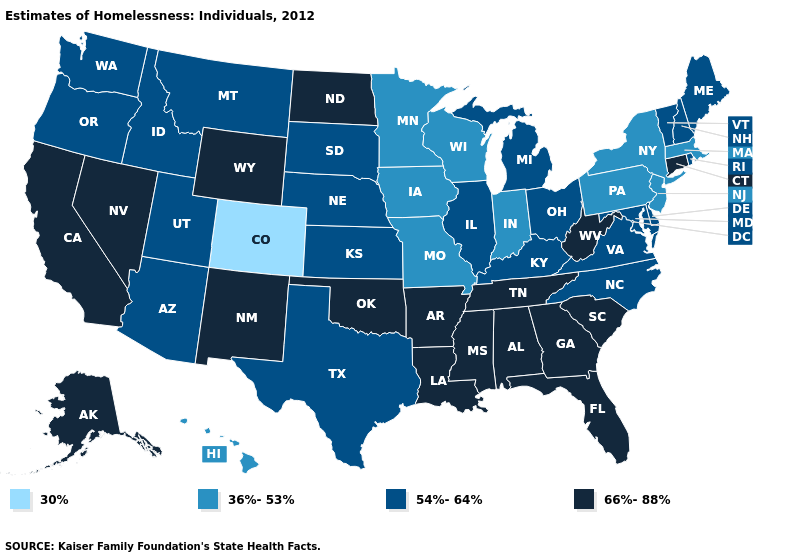Name the states that have a value in the range 54%-64%?
Short answer required. Arizona, Delaware, Idaho, Illinois, Kansas, Kentucky, Maine, Maryland, Michigan, Montana, Nebraska, New Hampshire, North Carolina, Ohio, Oregon, Rhode Island, South Dakota, Texas, Utah, Vermont, Virginia, Washington. Name the states that have a value in the range 66%-88%?
Write a very short answer. Alabama, Alaska, Arkansas, California, Connecticut, Florida, Georgia, Louisiana, Mississippi, Nevada, New Mexico, North Dakota, Oklahoma, South Carolina, Tennessee, West Virginia, Wyoming. Does Kansas have the same value as Idaho?
Concise answer only. Yes. Does Louisiana have a lower value than New Jersey?
Quick response, please. No. What is the value of Nevada?
Keep it brief. 66%-88%. Which states hav the highest value in the MidWest?
Quick response, please. North Dakota. Name the states that have a value in the range 30%?
Give a very brief answer. Colorado. Does the first symbol in the legend represent the smallest category?
Concise answer only. Yes. What is the value of Maryland?
Quick response, please. 54%-64%. What is the value of South Dakota?
Be succinct. 54%-64%. Name the states that have a value in the range 30%?
Answer briefly. Colorado. Name the states that have a value in the range 36%-53%?
Be succinct. Hawaii, Indiana, Iowa, Massachusetts, Minnesota, Missouri, New Jersey, New York, Pennsylvania, Wisconsin. Which states have the highest value in the USA?
Keep it brief. Alabama, Alaska, Arkansas, California, Connecticut, Florida, Georgia, Louisiana, Mississippi, Nevada, New Mexico, North Dakota, Oklahoma, South Carolina, Tennessee, West Virginia, Wyoming. Name the states that have a value in the range 36%-53%?
Quick response, please. Hawaii, Indiana, Iowa, Massachusetts, Minnesota, Missouri, New Jersey, New York, Pennsylvania, Wisconsin. 